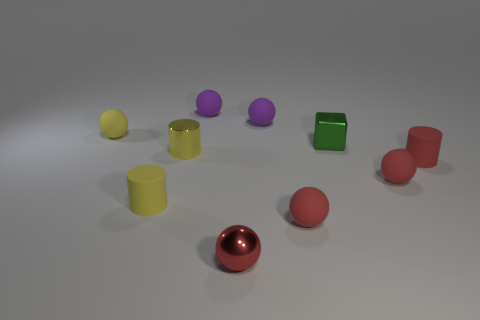There is a small red shiny thing; is it the same shape as the tiny yellow matte object behind the tiny green metallic thing?
Provide a short and direct response. Yes. There is a yellow rubber thing that is in front of the cube; does it have the same size as the red metallic ball?
Your response must be concise. Yes. What shape is the green object that is the same size as the metal sphere?
Keep it short and to the point. Cube. Is the green metallic thing the same shape as the red metal thing?
Offer a very short reply. No. How many small red shiny things have the same shape as the yellow metal thing?
Ensure brevity in your answer.  0. There is a tiny shiny cube; what number of tiny cylinders are in front of it?
Keep it short and to the point. 3. Does the cylinder to the right of the red metallic ball have the same color as the cube?
Ensure brevity in your answer.  No. What number of other rubber cylinders are the same size as the yellow matte cylinder?
Ensure brevity in your answer.  1. What shape is the red object that is made of the same material as the tiny green block?
Offer a terse response. Sphere. Is there a small rubber cylinder that has the same color as the metallic ball?
Make the answer very short. Yes. 